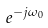Convert formula to latex. <formula><loc_0><loc_0><loc_500><loc_500>e ^ { - j \omega _ { 0 } }</formula> 